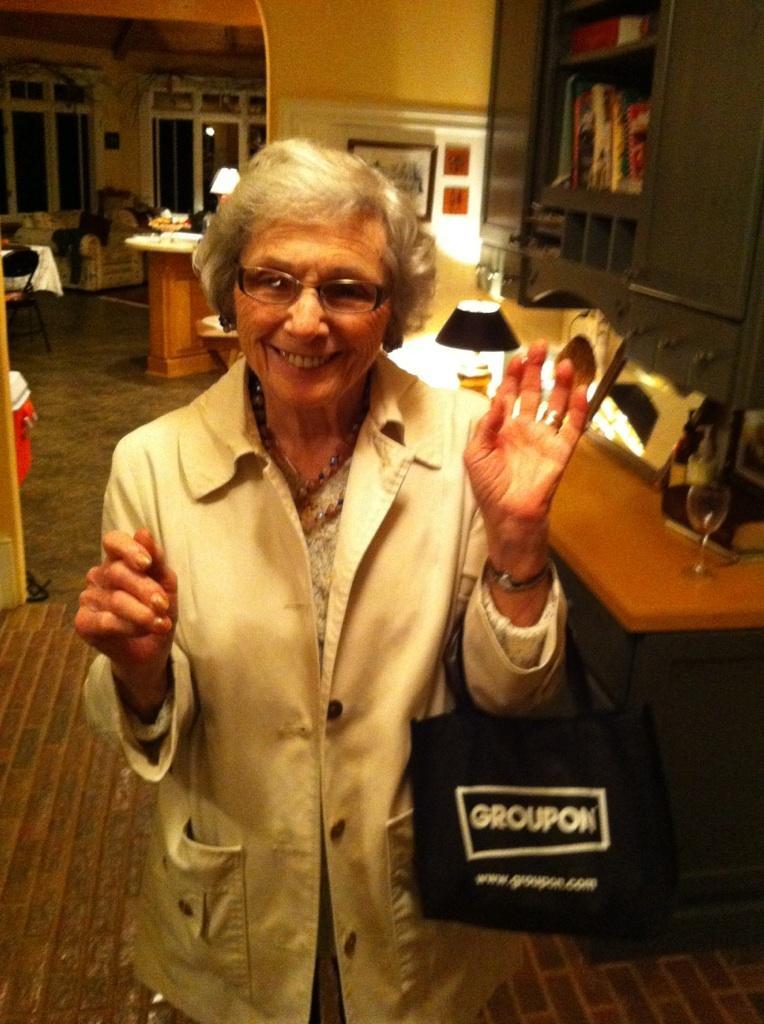Please provide a concise description of this image. In this picture I can see a woman is standing. The woman is smiling and holding a bag. On the right side I can see a table on which I can see glass and other objects. In the background I can see light lamps and wall. On the left side I can see a chair, windows and other objects on the floor. 